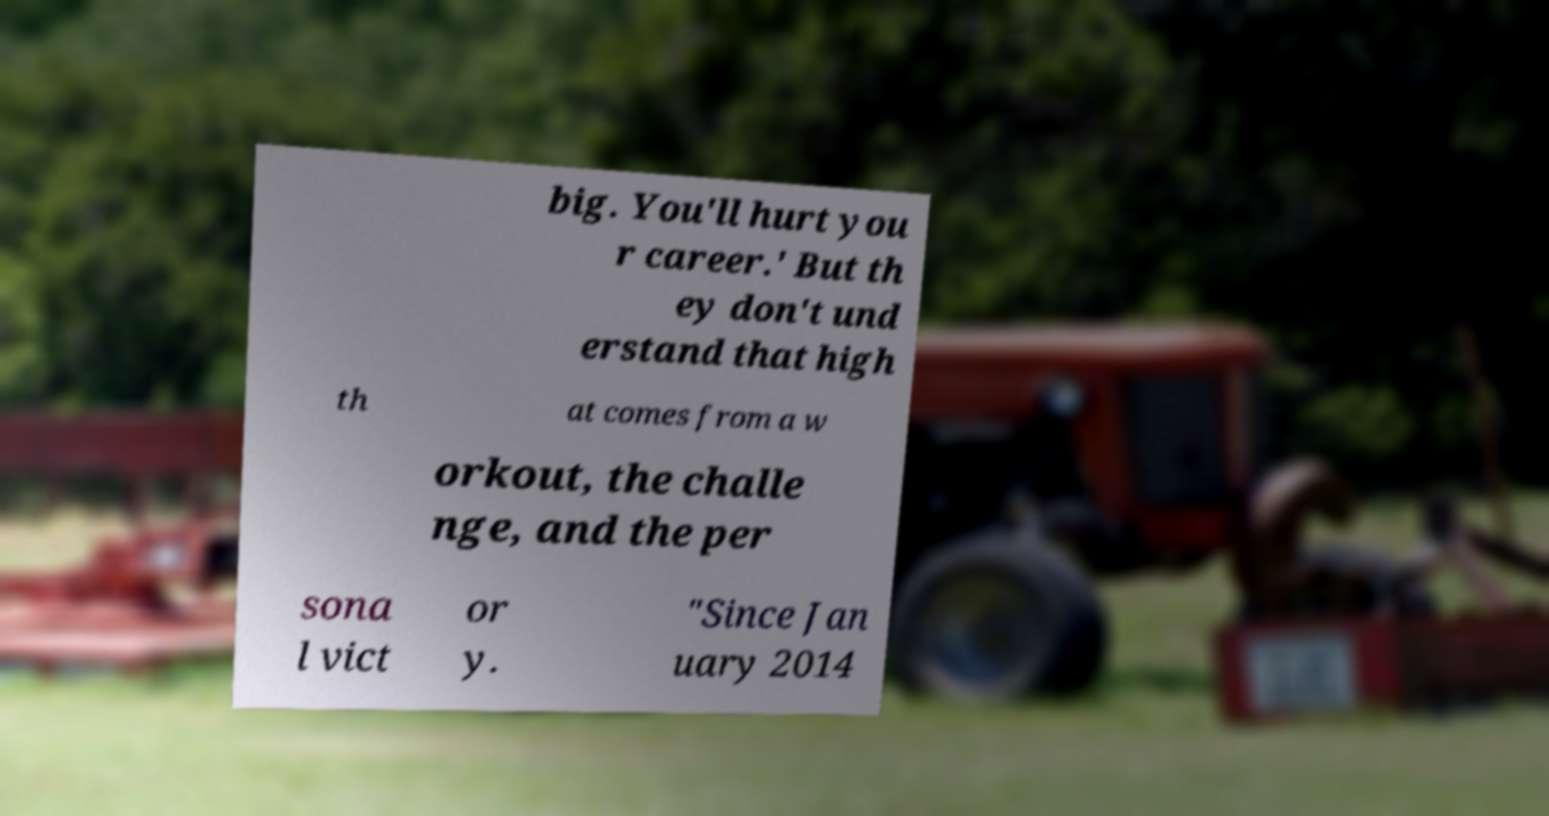I need the written content from this picture converted into text. Can you do that? big. You'll hurt you r career.' But th ey don't und erstand that high th at comes from a w orkout, the challe nge, and the per sona l vict or y. "Since Jan uary 2014 